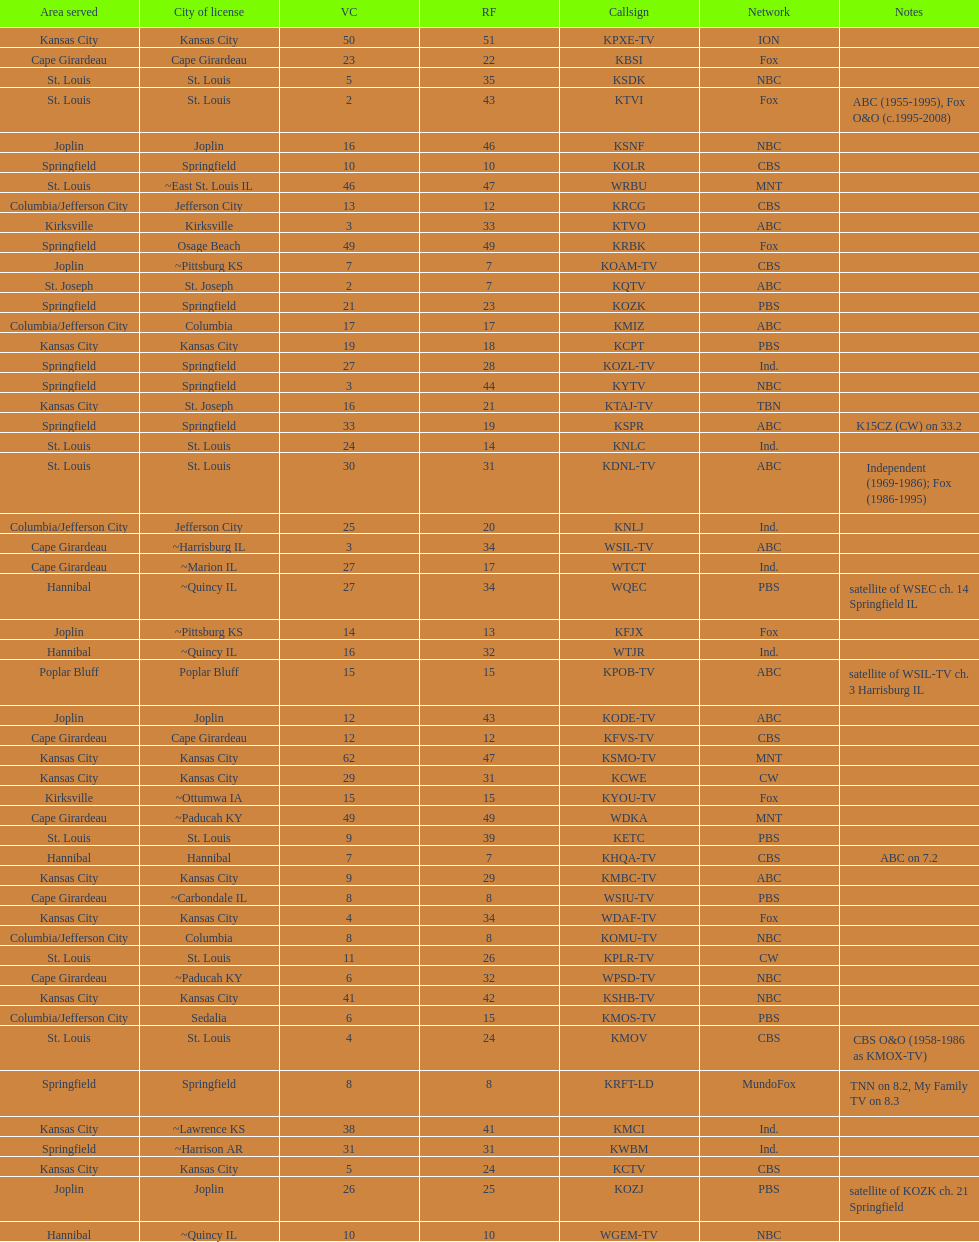Parse the full table. {'header': ['Area served', 'City of license', 'VC', 'RF', 'Callsign', 'Network', 'Notes'], 'rows': [['Kansas City', 'Kansas City', '50', '51', 'KPXE-TV', 'ION', ''], ['Cape Girardeau', 'Cape Girardeau', '23', '22', 'KBSI', 'Fox', ''], ['St. Louis', 'St. Louis', '5', '35', 'KSDK', 'NBC', ''], ['St. Louis', 'St. Louis', '2', '43', 'KTVI', 'Fox', 'ABC (1955-1995), Fox O&O (c.1995-2008)'], ['Joplin', 'Joplin', '16', '46', 'KSNF', 'NBC', ''], ['Springfield', 'Springfield', '10', '10', 'KOLR', 'CBS', ''], ['St. Louis', '~East St. Louis IL', '46', '47', 'WRBU', 'MNT', ''], ['Columbia/Jefferson City', 'Jefferson City', '13', '12', 'KRCG', 'CBS', ''], ['Kirksville', 'Kirksville', '3', '33', 'KTVO', 'ABC', ''], ['Springfield', 'Osage Beach', '49', '49', 'KRBK', 'Fox', ''], ['Joplin', '~Pittsburg KS', '7', '7', 'KOAM-TV', 'CBS', ''], ['St. Joseph', 'St. Joseph', '2', '7', 'KQTV', 'ABC', ''], ['Springfield', 'Springfield', '21', '23', 'KOZK', 'PBS', ''], ['Columbia/Jefferson City', 'Columbia', '17', '17', 'KMIZ', 'ABC', ''], ['Kansas City', 'Kansas City', '19', '18', 'KCPT', 'PBS', ''], ['Springfield', 'Springfield', '27', '28', 'KOZL-TV', 'Ind.', ''], ['Springfield', 'Springfield', '3', '44', 'KYTV', 'NBC', ''], ['Kansas City', 'St. Joseph', '16', '21', 'KTAJ-TV', 'TBN', ''], ['Springfield', 'Springfield', '33', '19', 'KSPR', 'ABC', 'K15CZ (CW) on 33.2'], ['St. Louis', 'St. Louis', '24', '14', 'KNLC', 'Ind.', ''], ['St. Louis', 'St. Louis', '30', '31', 'KDNL-TV', 'ABC', 'Independent (1969-1986); Fox (1986-1995)'], ['Columbia/Jefferson City', 'Jefferson City', '25', '20', 'KNLJ', 'Ind.', ''], ['Cape Girardeau', '~Harrisburg IL', '3', '34', 'WSIL-TV', 'ABC', ''], ['Cape Girardeau', '~Marion IL', '27', '17', 'WTCT', 'Ind.', ''], ['Hannibal', '~Quincy IL', '27', '34', 'WQEC', 'PBS', 'satellite of WSEC ch. 14 Springfield IL'], ['Joplin', '~Pittsburg KS', '14', '13', 'KFJX', 'Fox', ''], ['Hannibal', '~Quincy IL', '16', '32', 'WTJR', 'Ind.', ''], ['Poplar Bluff', 'Poplar Bluff', '15', '15', 'KPOB-TV', 'ABC', 'satellite of WSIL-TV ch. 3 Harrisburg IL'], ['Joplin', 'Joplin', '12', '43', 'KODE-TV', 'ABC', ''], ['Cape Girardeau', 'Cape Girardeau', '12', '12', 'KFVS-TV', 'CBS', ''], ['Kansas City', 'Kansas City', '62', '47', 'KSMO-TV', 'MNT', ''], ['Kansas City', 'Kansas City', '29', '31', 'KCWE', 'CW', ''], ['Kirksville', '~Ottumwa IA', '15', '15', 'KYOU-TV', 'Fox', ''], ['Cape Girardeau', '~Paducah KY', '49', '49', 'WDKA', 'MNT', ''], ['St. Louis', 'St. Louis', '9', '39', 'KETC', 'PBS', ''], ['Hannibal', 'Hannibal', '7', '7', 'KHQA-TV', 'CBS', 'ABC on 7.2'], ['Kansas City', 'Kansas City', '9', '29', 'KMBC-TV', 'ABC', ''], ['Cape Girardeau', '~Carbondale IL', '8', '8', 'WSIU-TV', 'PBS', ''], ['Kansas City', 'Kansas City', '4', '34', 'WDAF-TV', 'Fox', ''], ['Columbia/Jefferson City', 'Columbia', '8', '8', 'KOMU-TV', 'NBC', ''], ['St. Louis', 'St. Louis', '11', '26', 'KPLR-TV', 'CW', ''], ['Cape Girardeau', '~Paducah KY', '6', '32', 'WPSD-TV', 'NBC', ''], ['Kansas City', 'Kansas City', '41', '42', 'KSHB-TV', 'NBC', ''], ['Columbia/Jefferson City', 'Sedalia', '6', '15', 'KMOS-TV', 'PBS', ''], ['St. Louis', 'St. Louis', '4', '24', 'KMOV', 'CBS', 'CBS O&O (1958-1986 as KMOX-TV)'], ['Springfield', 'Springfield', '8', '8', 'KRFT-LD', 'MundoFox', 'TNN on 8.2, My Family TV on 8.3'], ['Kansas City', '~Lawrence KS', '38', '41', 'KMCI', 'Ind.', ''], ['Springfield', '~Harrison AR', '31', '31', 'KWBM', 'Ind.', ''], ['Kansas City', 'Kansas City', '5', '24', 'KCTV', 'CBS', ''], ['Joplin', 'Joplin', '26', '25', 'KOZJ', 'PBS', 'satellite of KOZK ch. 21 Springfield'], ['Hannibal', '~Quincy IL', '10', '10', 'WGEM-TV', 'NBC', '']]} How many television stations serve the cape girardeau area? 7. 